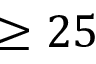Convert formula to latex. <formula><loc_0><loc_0><loc_500><loc_500>\geq 2 5</formula> 